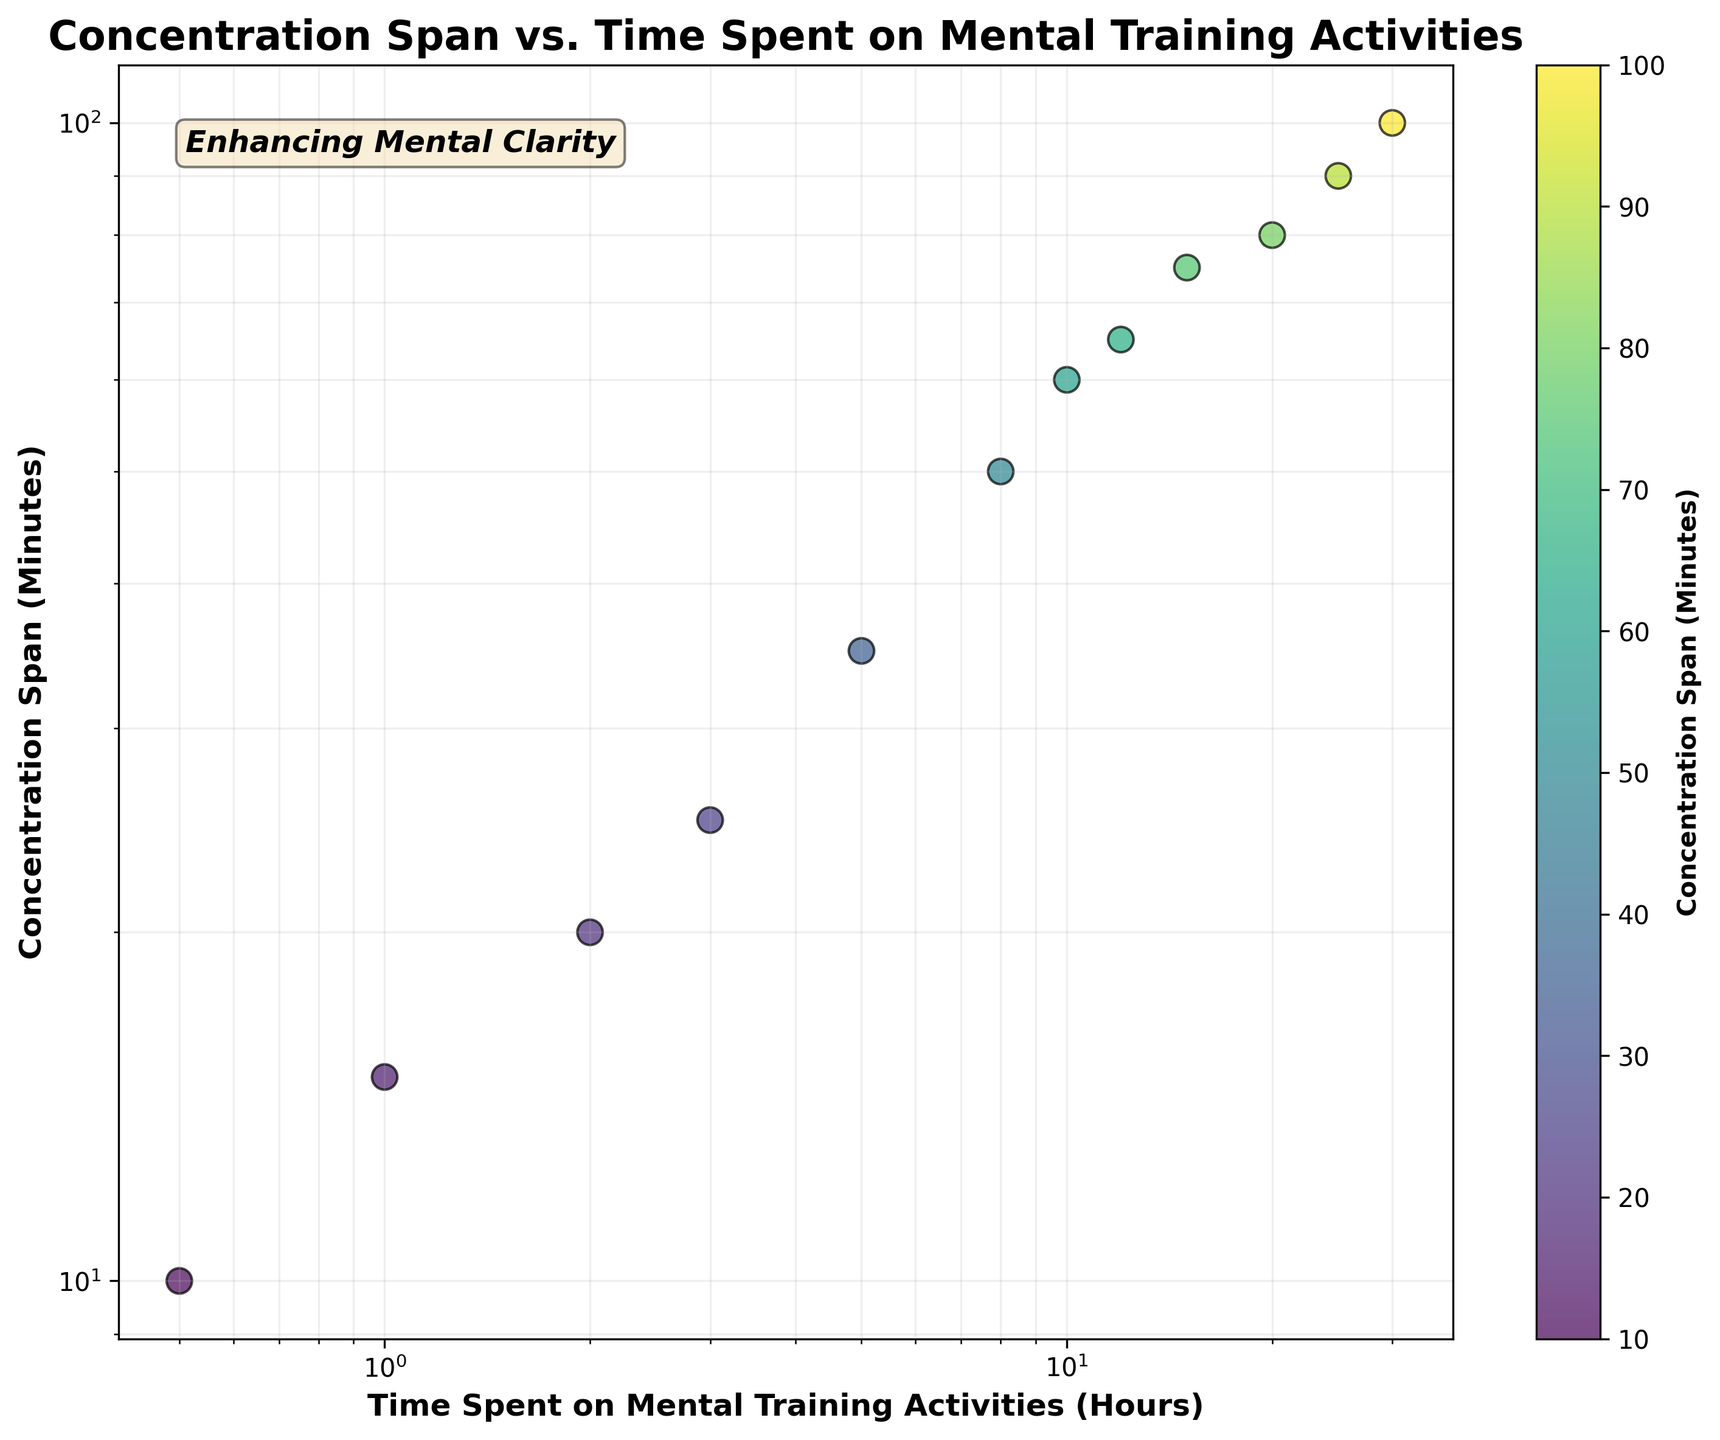what information is in the title of the plot? The title of the plot is "Concentration Span vs. Time Spent on Mental Training Activities." This indicates that the scatter plot shows the relationship between concentration span (measured in minutes) and the time spent on mental training activities (measured in hours).
Answer: Concentration Span vs. Time Spent on Mental Training Activities How many data points are in the plot? The plot contains 12 data points, as seen from the number of individual markers on the graph. Each marker represents a pair of time spent on mental training activities and the corresponding concentration span.
Answer: 12 What is the range of the x-axis on the plot? The x-axis represents the time spent on mental training activities in hours and it uses a logarithmic scale. The data points start from 0.5 hours and go up to 30 hours, indicating that the range is from 0.5 to 30 hours.
Answer: 0.5 to 30 hours Which data point has the highest concentration span? By observing the scatter plot, the data point at the top of the y-axis represents the highest concentration span. This point corresponds to 30 hours of mental training activities and a concentration span of 100 minutes.
Answer: 100 minutes Does a higher time spent on mental activities generally correspond to a higher concentration span? By observing the scatter plot, it is evident that as the time spent on mental training activities increases, the concentration span also increases. The data points generally follow a trend in the upward direction.
Answer: Yes What is the concentration span for 10 hours spent on mental training activities? From the scatter plot, the point corresponding to 10 hours of mental training activities has a concentration span of 60 minutes.
Answer: 60 minutes Compare the concentration spans at 5 hours and 20 hours of mental training activities. Which one is higher and by how much? Observing the scatter plot, at 5 hours the concentration span is 35 minutes, and at 20 hours it is 80 minutes. The difference is 80 - 35 = 45 minutes, and the span at 20 hours is higher.
Answer: 20 hours is higher by 45 minutes What do the colors of the data points represent? The colors of the data points represent the concentration span in minutes, as indicated by the color bar on the plot. Darker colors correspond to lower concentration spans, while brighter colors correspond to higher spans.
Answer: Concentration span in minutes What is the label for the x-axis? The label for the x-axis is "Time Spent on Mental Training Activities (Hours)." This indicates that the horizontal scale measures the amount of time spent on mental training.
Answer: Time Spent on Mental Training Activities (Hours) At what hour of mental training do we see a concentration span of 50 minutes? Referring to the scatter plot, around 8 hours of mental training activities corresponds to a concentration span of 50 minutes.
Answer: 8 hours 